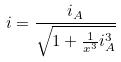<formula> <loc_0><loc_0><loc_500><loc_500>i = \frac { i _ { A } } { \sqrt { 1 + \frac { 1 } { x ^ { 3 } } i _ { A } ^ { 3 } } }</formula> 